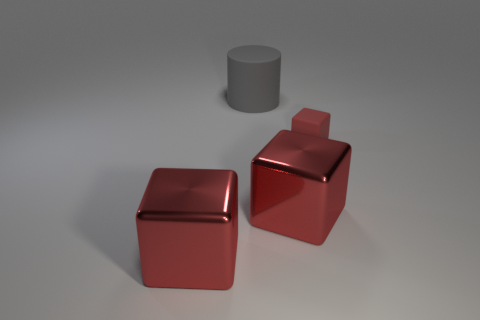Add 3 tiny red shiny cylinders. How many objects exist? 7 Subtract all cubes. How many objects are left? 1 Add 2 big matte objects. How many big matte objects are left? 3 Add 4 yellow metallic spheres. How many yellow metallic spheres exist? 4 Subtract 0 cyan cubes. How many objects are left? 4 Subtract all red metal things. Subtract all red rubber objects. How many objects are left? 1 